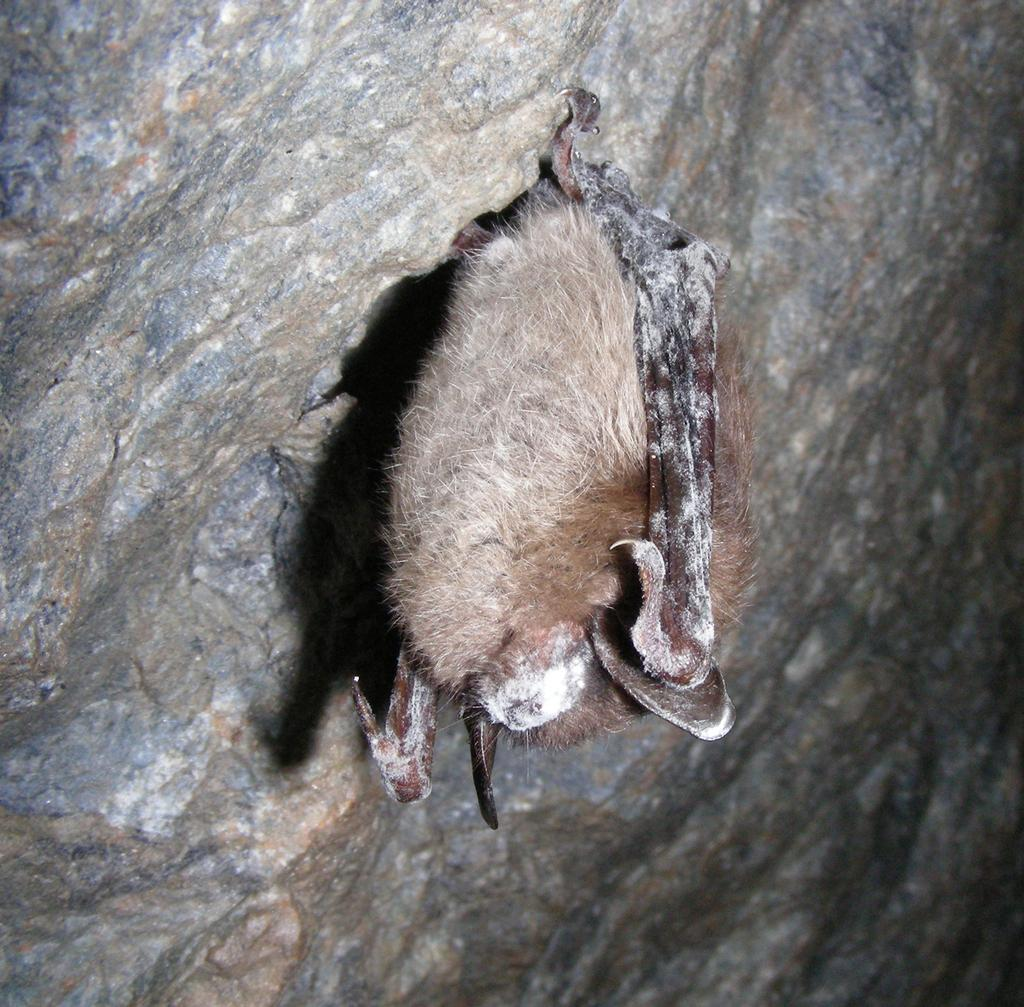Where was the image taken? The image was clicked outside. What is the main subject in the image? There is a bat-like thing in the image. What is the bat-like thing doing in the image? The bat-like thing is hanging on a rock. What type of stitch is being used to sew the bat's tail in the image? There is no bat's tail present in the image, nor is there any indication of sewing or stitching. 